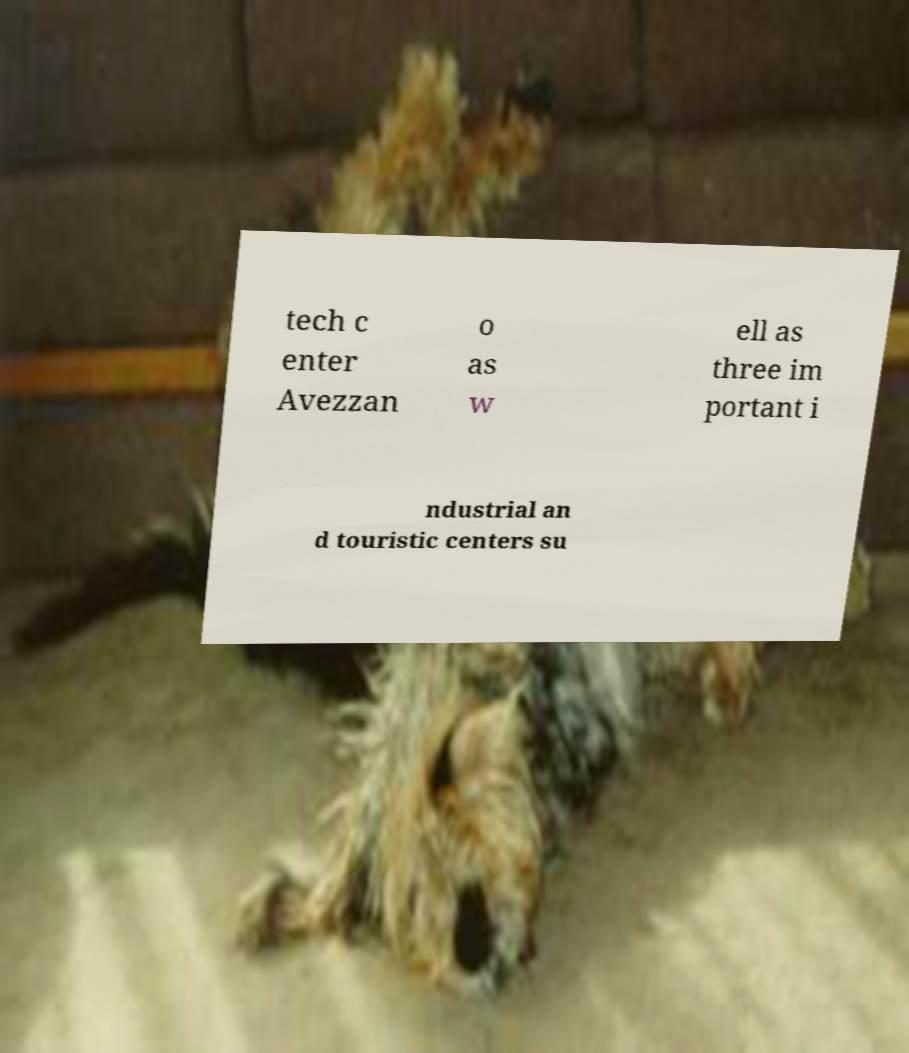Could you extract and type out the text from this image? tech c enter Avezzan o as w ell as three im portant i ndustrial an d touristic centers su 